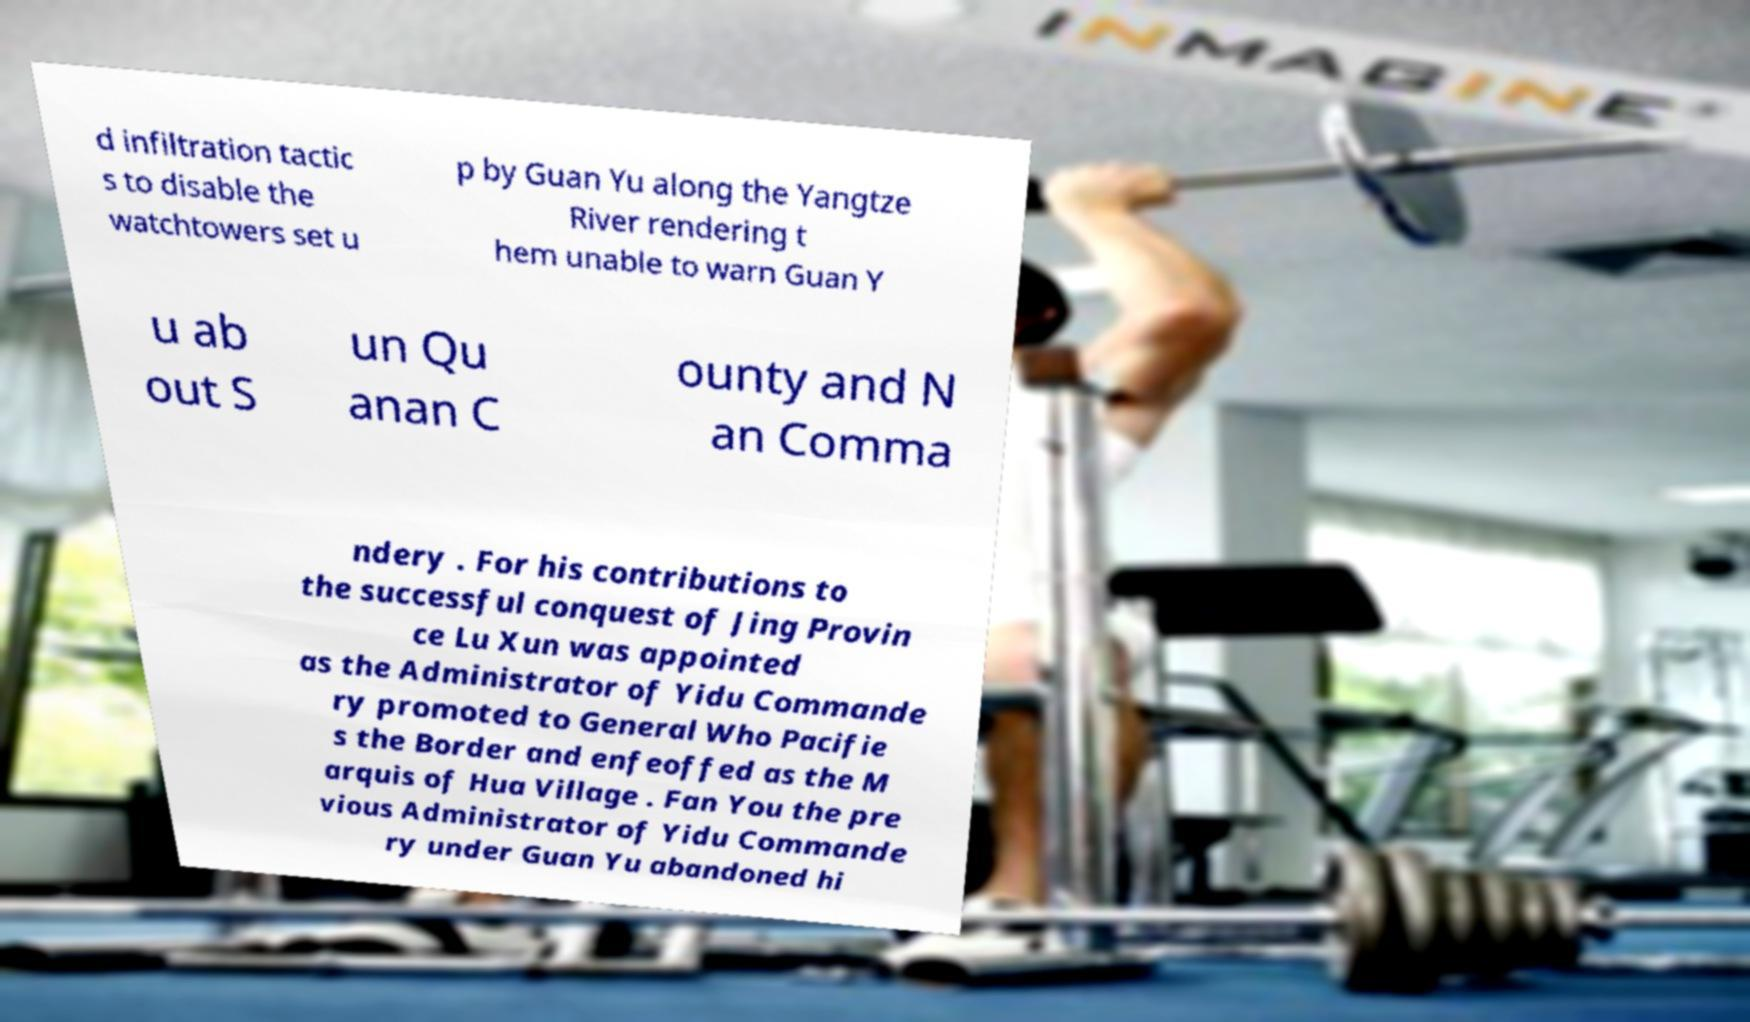Please read and relay the text visible in this image. What does it say? d infiltration tactic s to disable the watchtowers set u p by Guan Yu along the Yangtze River rendering t hem unable to warn Guan Y u ab out S un Qu anan C ounty and N an Comma ndery . For his contributions to the successful conquest of Jing Provin ce Lu Xun was appointed as the Administrator of Yidu Commande ry promoted to General Who Pacifie s the Border and enfeoffed as the M arquis of Hua Village . Fan You the pre vious Administrator of Yidu Commande ry under Guan Yu abandoned hi 